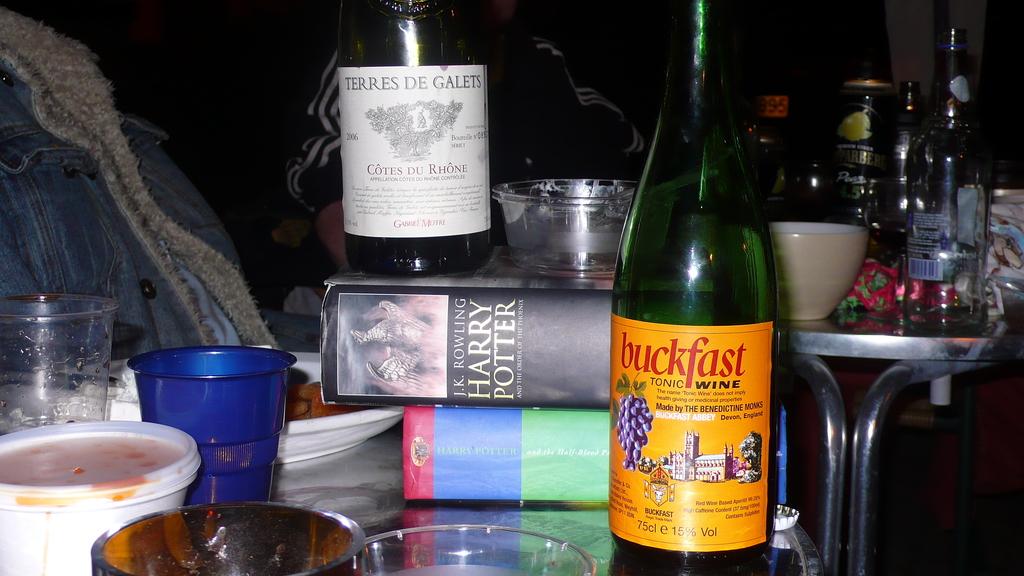What name is mentioned on the wine bottle?
Your answer should be very brief. Buckfast. 